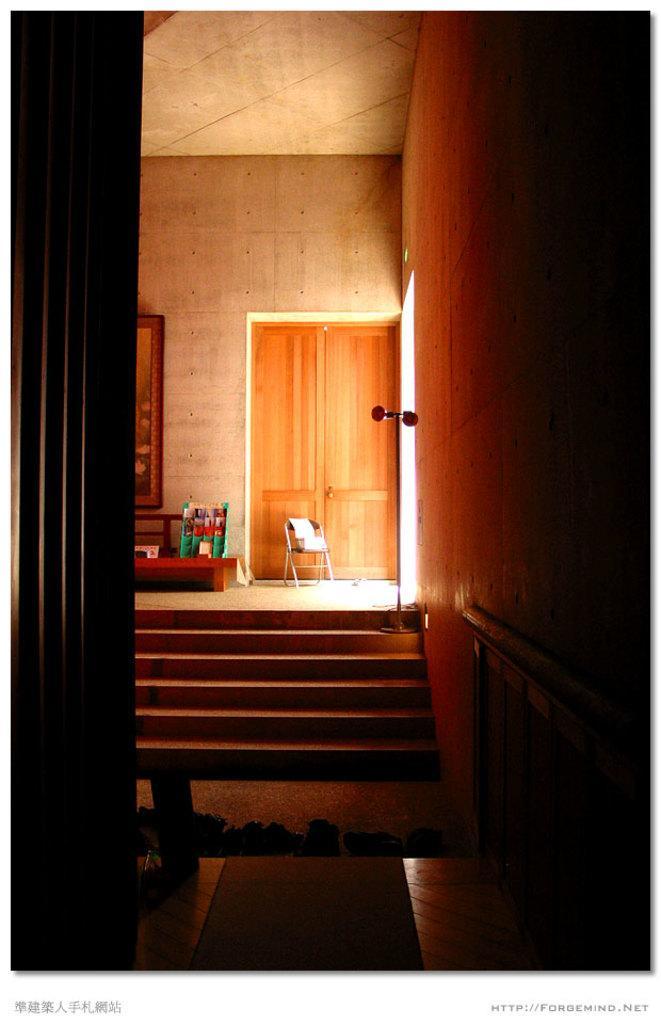How would you summarize this image in a sentence or two? In this image we can see staircase, railing, glass, door, wall hanging and a chair on the floor. 